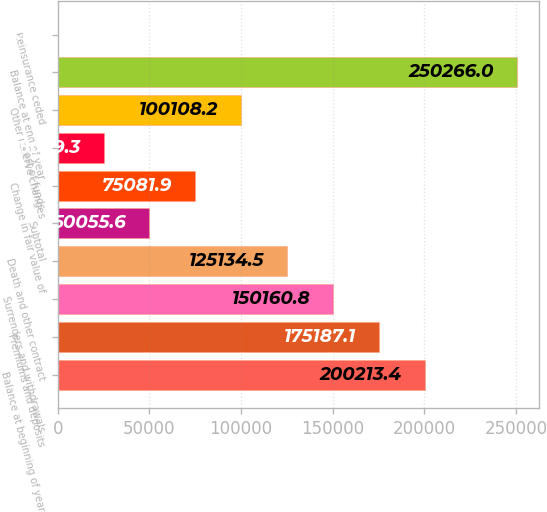Convert chart to OTSL. <chart><loc_0><loc_0><loc_500><loc_500><bar_chart><fcel>Balance at beginning of year<fcel>Premiums and deposits<fcel>Surrenders and withdrawals<fcel>Death and other contract<fcel>Subtotal<fcel>Change in fair value of<fcel>Cost of funds<fcel>Other reserve changes<fcel>Balance at end of year<fcel>Reinsurance ceded<nl><fcel>200213<fcel>175187<fcel>150161<fcel>125134<fcel>50055.6<fcel>75081.9<fcel>25029.3<fcel>100108<fcel>250266<fcel>3<nl></chart> 